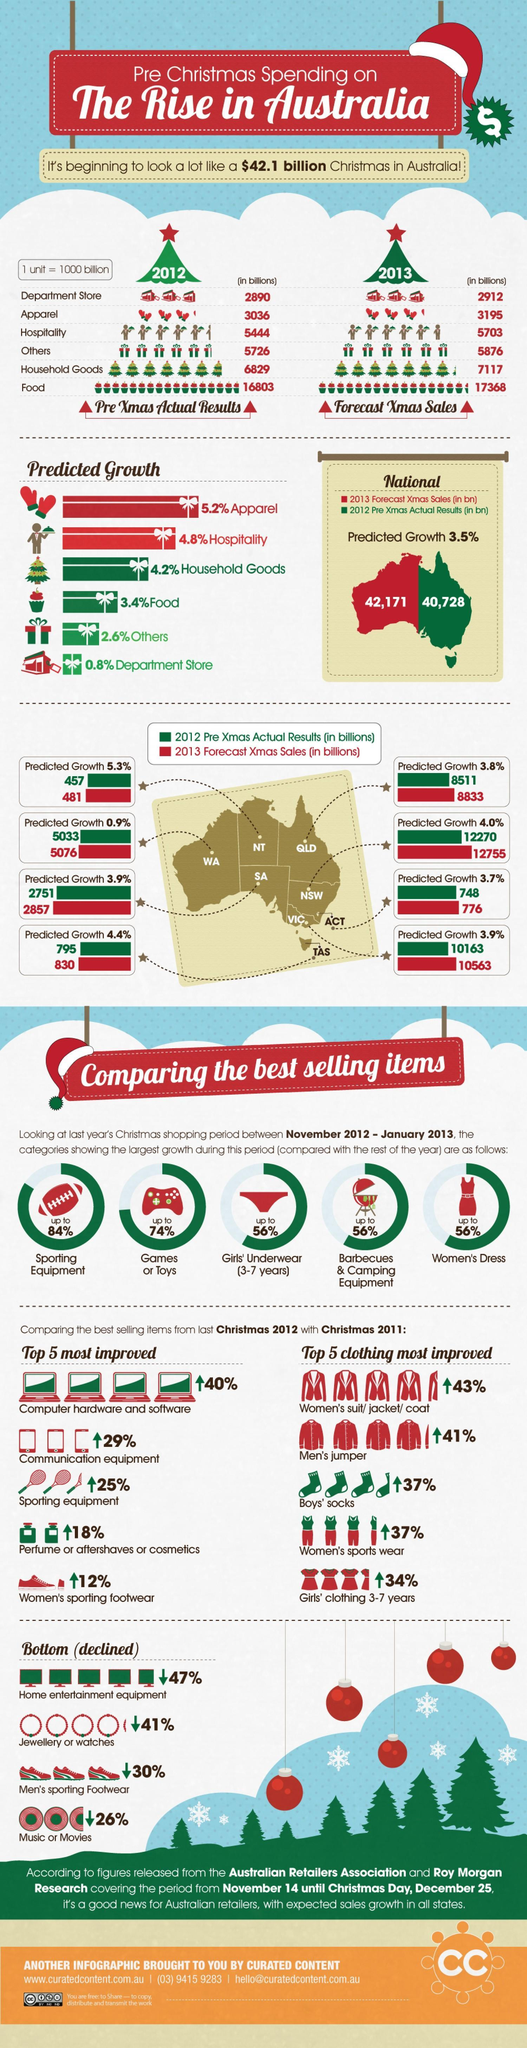Which item in clothing shows an rise by 41%, Men's jumper, Boy's Socks or Women's sports wear?
Answer the question with a short phrase. Men's jumper Which item recorded the highest sales in 2012, Others, Food, or Apparel? Food Which state records the maximum forecast of growth in terms of sales ? NT What is the increase in sales of household goods expected from 2012 to 2013 ? 288 What is the difference in the numbers of the Xmas sales between 2013 and 2012 ? 1,443 How many categories register a growth of 56% in the period 2012-2013 ? 3 Which state shows the highest predicted sales for XMas in 2013? NSW Which state shows the lowest Xmas sales recorded in 2012 ? NT What is the predicted increase in the category of 'Others' in 2013? 5876 